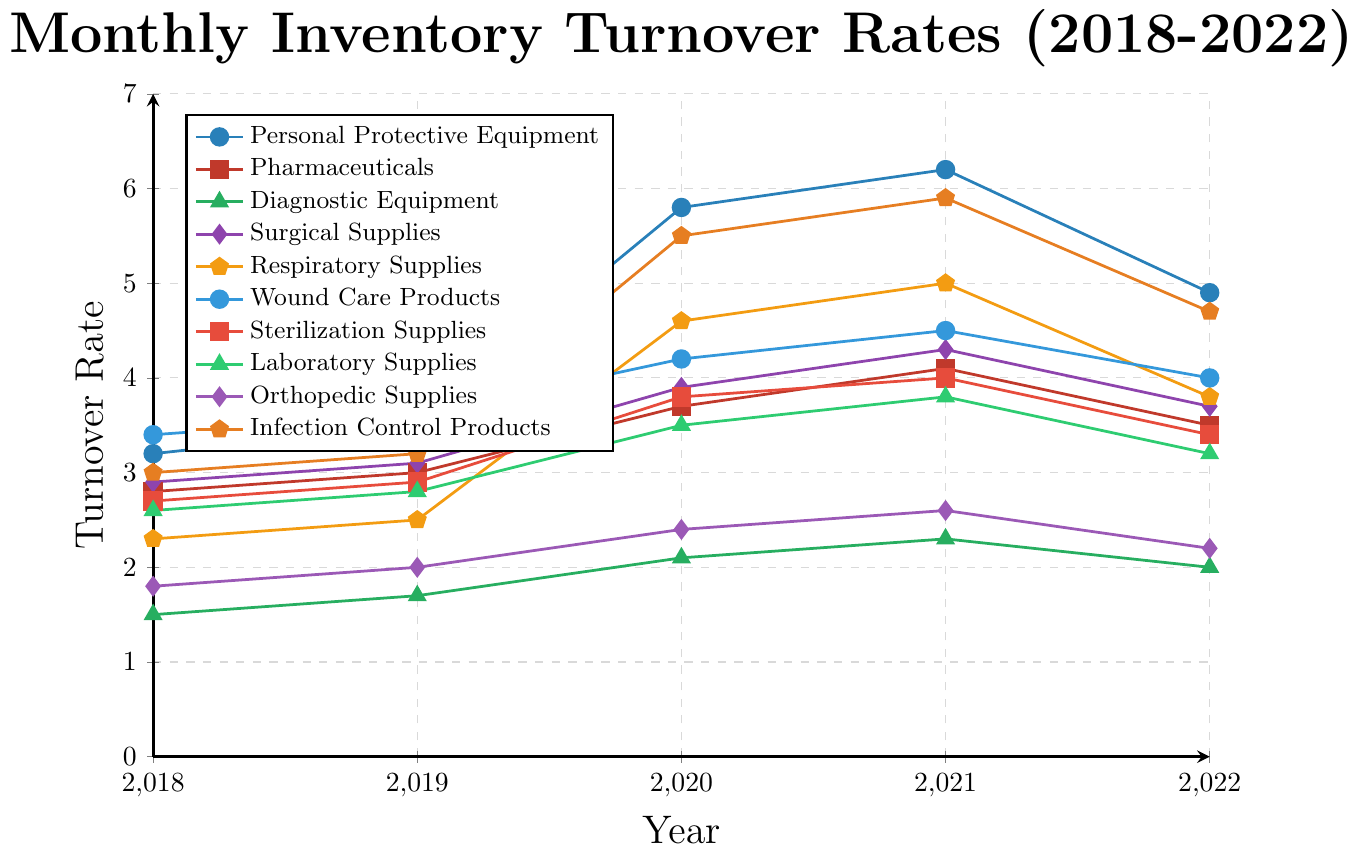Which category has the highest turnover rate in 2021? Look at all the values listed under 2021 and identify the highest value. Personal Protective Equipment has a turnover rate of 6.2, which is the highest in that year.
Answer: Personal Protective Equipment Which year saw the largest increase in turnover rate for Diagnostic Equipment? Compare the turnover rates for Diagnostic Equipment year by year. The largest increase is from 2019 to 2020 (from 1.7 to 2.1, an increase of 0.4).
Answer: 2020 What is the average turnover rate for Pharmaceuticals over the 5-year period? Sum the turnover rates for Pharmaceuticals (2.8 + 3.0 + 3.7 + 4.1 + 3.5) and divide by 5. The sum is 17.1, and the average is 17.1/5.
Answer: 3.42 How did the turnover rate for Respiratory Supplies change from 2020 to 2022? Look at the turnover rates for Respiratory Supplies for the years 2020, 2021, and 2022: 4.6, 5.0, and 3.8 respectively. The rate increased from 2020 to 2021, then decreased from 2021 to 2022.
Answer: Increased, then decreased Which category has the lowest turnover rate in 2022? Look at all the values listed under 2022 and identify the lowest value. Orthopedic Supplies has the lowest turnover rate of 2.2.
Answer: Orthopedic Supplies What color represents Infection Control Products in the chart? Identify the line corresponding to Infection Control Products and note the color. Infection Control Products are represented by an orange-colored line.
Answer: Orange Compare the turnover rate trends for Surgical Supplies and Sterilization Supplies from 2018 to 2022. Analyze the turnover rates for Surgical Supplies and Sterilization Supplies over the years. Both categories show an increasing trend up to 2021 and then a decrease in 2022. Surgical Supplies had rates of 2.9, 3.1, 3.9, 4.3, and 3.7, while Sterilization Supplies had rates of 2.7, 2.9, 3.8, 4.0, and 3.4.
Answer: Both increased to 2021 then decreased What is the difference in turnover rates between Wound Care Products and Laboratory Supplies in 2022? Find the turnover rates for Wound Care Products (4.0) and Laboratory Supplies (3.2) in 2022 and calculate the difference: 4.0 - 3.2.
Answer: 0.8 By how much did the turnover rate for Personal Protective Equipment change from 2019 to 2020? Look at the turnover rates for Personal Protective Equipment for the years 2019 (3.5) and 2020 (5.8) and calculate the difference: 5.8 - 3.5.
Answer: 2.3 What is the trend of Orthopedic Supplies turnover rate from 2018 to 2022? Analyze the turnover rates for Orthopedic Supplies over the years 2018 (1.8), 2019 (2.0), 2020 (2.4), 2021 (2.6), and 2022 (2.2). The trend shows a gradual increase from 2018 to 2021 and a slight decrease in 2022.
Answer: Gradual increase, slight decrease 